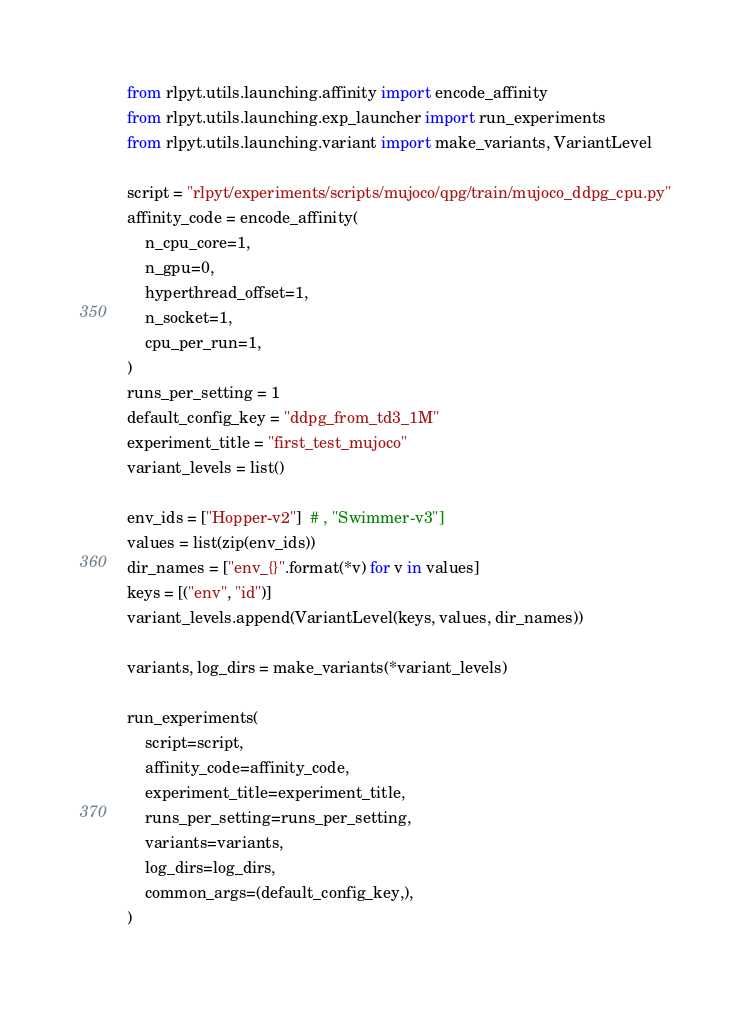<code> <loc_0><loc_0><loc_500><loc_500><_Python_>
from rlpyt.utils.launching.affinity import encode_affinity
from rlpyt.utils.launching.exp_launcher import run_experiments
from rlpyt.utils.launching.variant import make_variants, VariantLevel

script = "rlpyt/experiments/scripts/mujoco/qpg/train/mujoco_ddpg_cpu.py"
affinity_code = encode_affinity(
    n_cpu_core=1,
    n_gpu=0,
    hyperthread_offset=1,
    n_socket=1,
    cpu_per_run=1,
)
runs_per_setting = 1
default_config_key = "ddpg_from_td3_1M"
experiment_title = "first_test_mujoco"
variant_levels = list()

env_ids = ["Hopper-v2"]  # , "Swimmer-v3"]
values = list(zip(env_ids))
dir_names = ["env_{}".format(*v) for v in values]
keys = [("env", "id")]
variant_levels.append(VariantLevel(keys, values, dir_names))

variants, log_dirs = make_variants(*variant_levels)

run_experiments(
    script=script,
    affinity_code=affinity_code,
    experiment_title=experiment_title,
    runs_per_setting=runs_per_setting,
    variants=variants,
    log_dirs=log_dirs,
    common_args=(default_config_key,),
)
</code> 